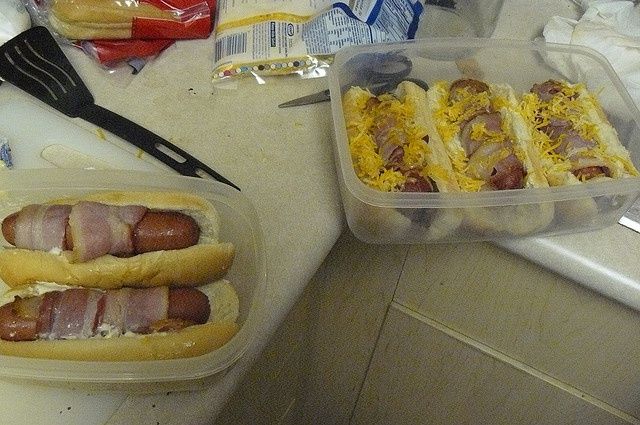Describe the objects in this image and their specific colors. I can see bowl in darkgray, tan, gray, and olive tones, bowl in darkgray, olive, and gray tones, hot dog in darkgray, olive, gray, and maroon tones, hot dog in darkgray, olive, gray, and maroon tones, and hot dog in darkgray and olive tones in this image. 